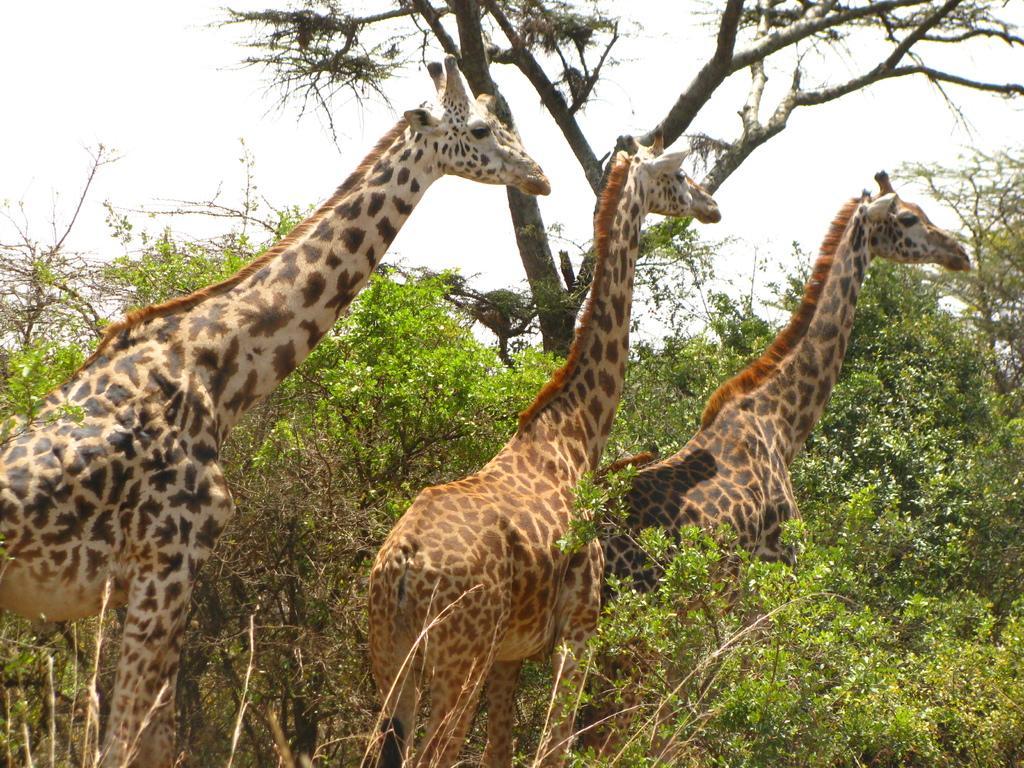Please provide a concise description of this image. 3 giraffes are standing facing towards the right. There are trees. 